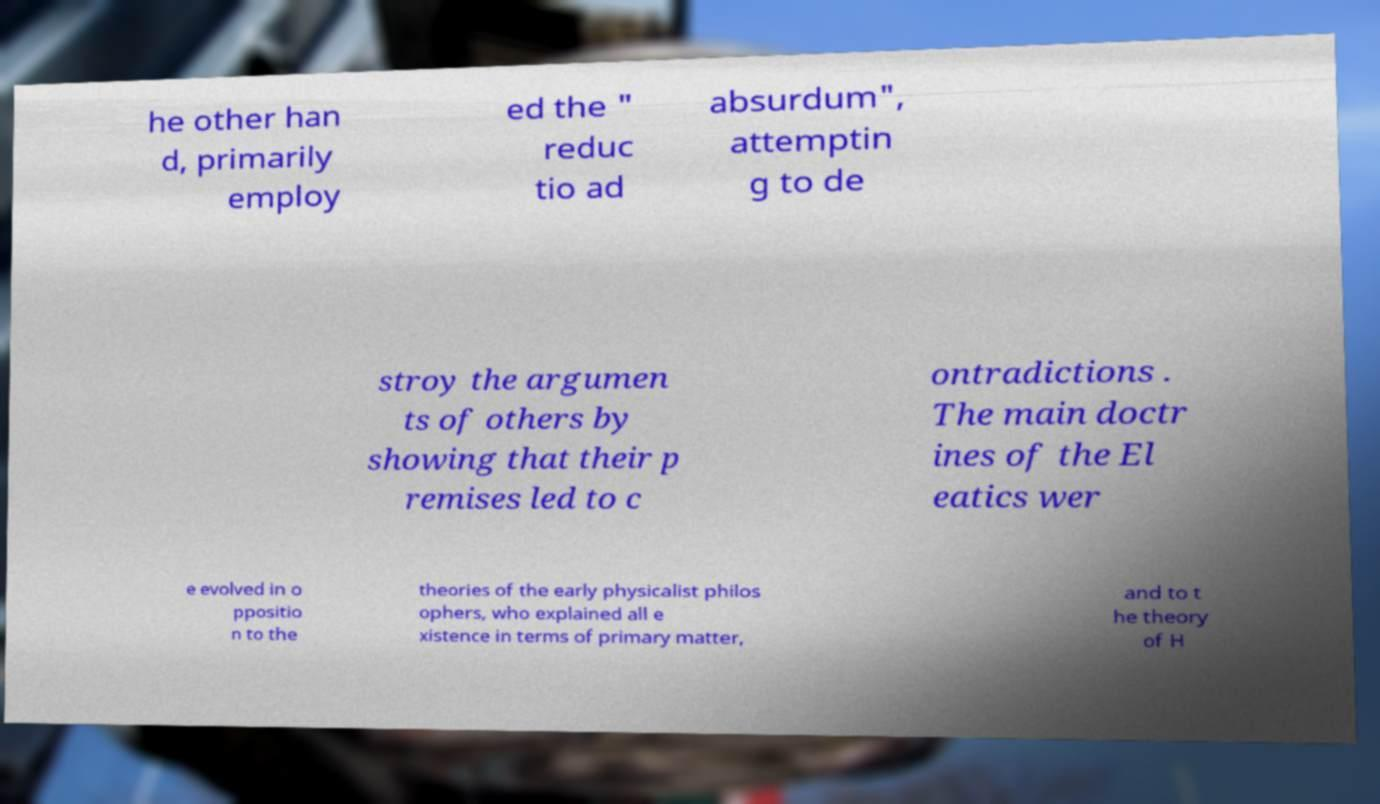I need the written content from this picture converted into text. Can you do that? he other han d, primarily employ ed the " reduc tio ad absurdum", attemptin g to de stroy the argumen ts of others by showing that their p remises led to c ontradictions . The main doctr ines of the El eatics wer e evolved in o ppositio n to the theories of the early physicalist philos ophers, who explained all e xistence in terms of primary matter, and to t he theory of H 